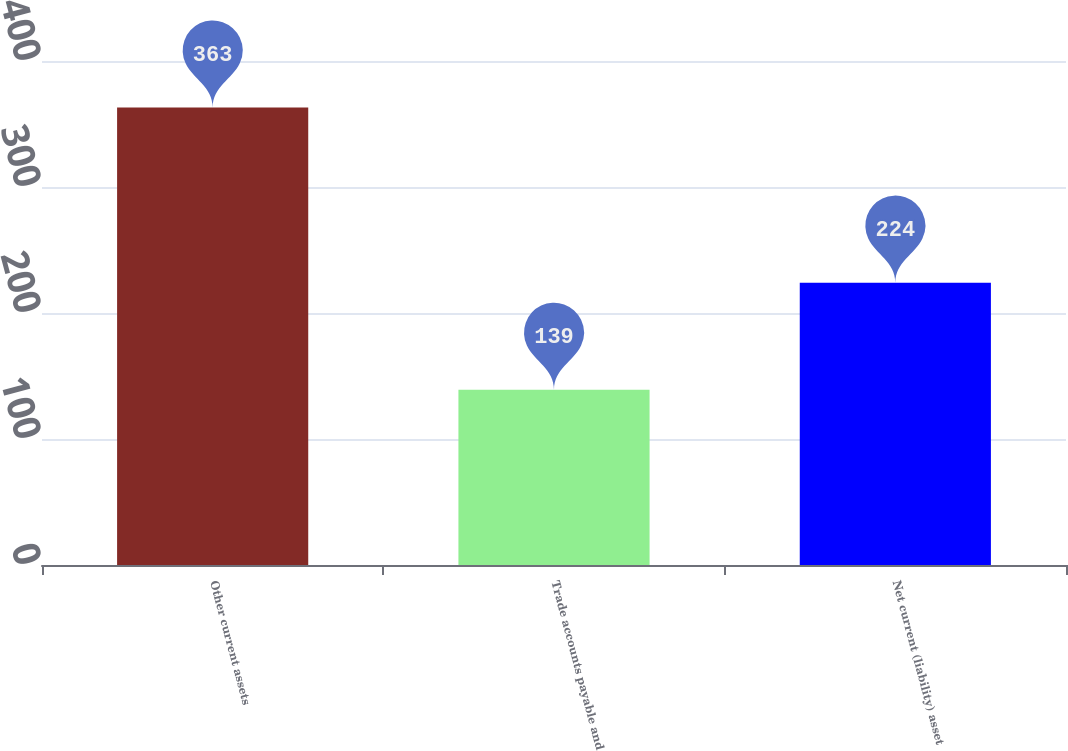Convert chart. <chart><loc_0><loc_0><loc_500><loc_500><bar_chart><fcel>Other current assets<fcel>Trade accounts payable and<fcel>Net current (liability) asset<nl><fcel>363<fcel>139<fcel>224<nl></chart> 